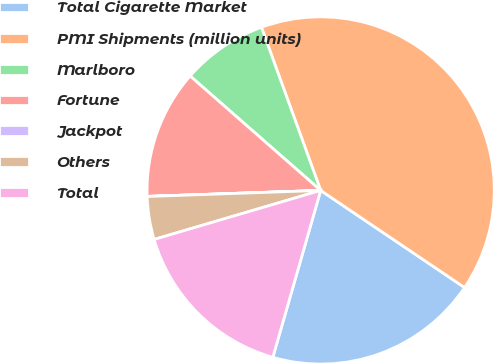Convert chart. <chart><loc_0><loc_0><loc_500><loc_500><pie_chart><fcel>Total Cigarette Market<fcel>PMI Shipments (million units)<fcel>Marlboro<fcel>Fortune<fcel>Jackpot<fcel>Others<fcel>Total<nl><fcel>20.0%<fcel>39.99%<fcel>8.0%<fcel>12.0%<fcel>0.01%<fcel>4.0%<fcel>16.0%<nl></chart> 